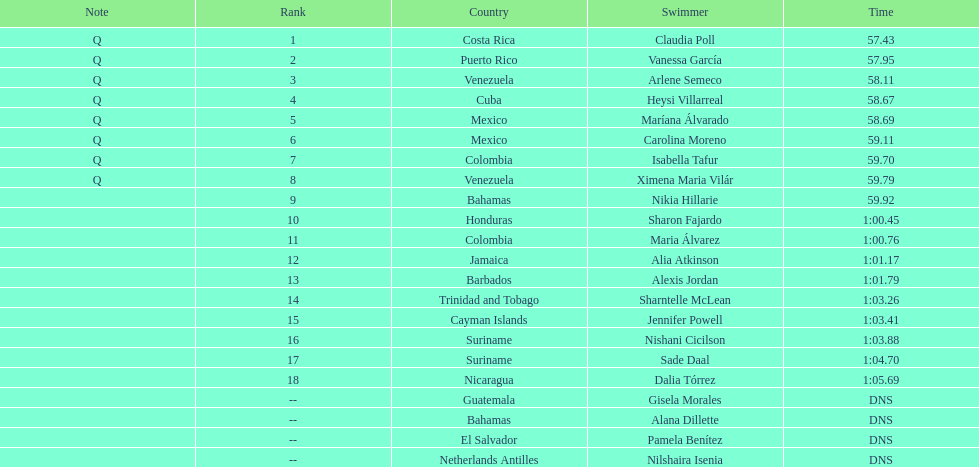Who was the last competitor to actually finish the preliminaries? Dalia Tórrez. 